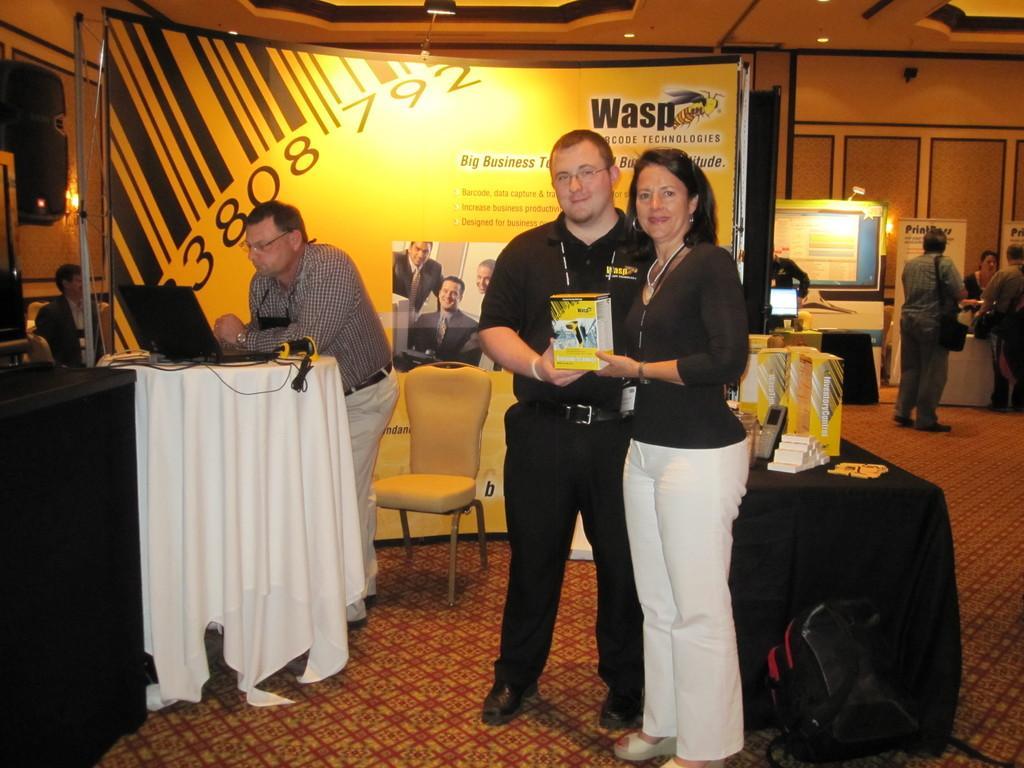Describe this image in one or two sentences. In this image I can see a man wearing black colored dress and a woman wearing black t shirt and white pant are standing and holding a box in their hands. I can see few tables, few objects on the tables, a black colored laptop on the table, a chair, few persons standing, a huge banner, a monitor, the wall, the ceiling and few lights to the ceiling in the background. 